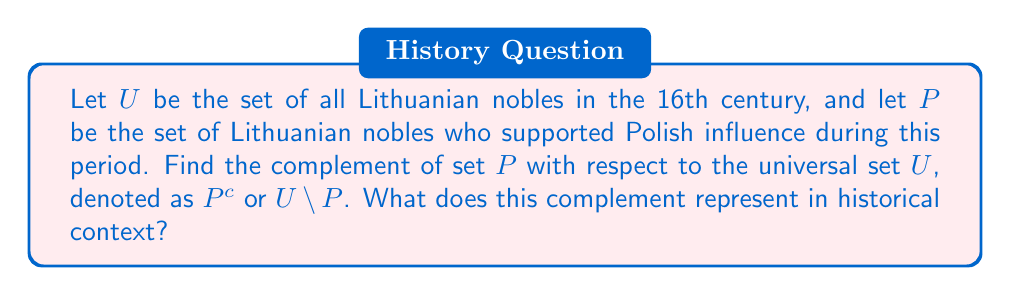Teach me how to tackle this problem. To solve this problem, we need to understand the concept of set complement and its historical significance:

1. The complement of a set $P$ with respect to a universal set $U$ is defined as all elements in $U$ that are not in $P$. Mathematically, this is represented as:

   $P^c = U \setminus P = \{x \in U : x \notin P\}$

2. In our historical context:
   - $U$ represents all Lithuanian nobles in the 16th century
   - $P$ represents Lithuanian nobles who supported Polish influence
   - $P^c$ will represent Lithuanian nobles who did not support Polish influence

3. The complement $P^c$ includes all nobles who:
   - Opposed Polish influence
   - Remained neutral
   - Supported other foreign influences (e.g., Russian, Swedish)
   - Advocated for Lithuanian independence

4. Historically, this complement is significant because it represents the faction of nobles who resisted the growing Polish cultural and political dominance in Lithuania during the 16th century, a critical period in the formation of the Polish-Lithuanian Commonwealth.

5. The size and composition of $P^c$ would have influenced Lithuania's ability to maintain its distinct identity within the Commonwealth and its relationships with neighboring powers.
Answer: $P^c = U \setminus P$ represents the set of Lithuanian nobles in the 16th century who did not support Polish influence, including those who opposed it, remained neutral, supported other foreign influences, or advocated for Lithuanian independence. 